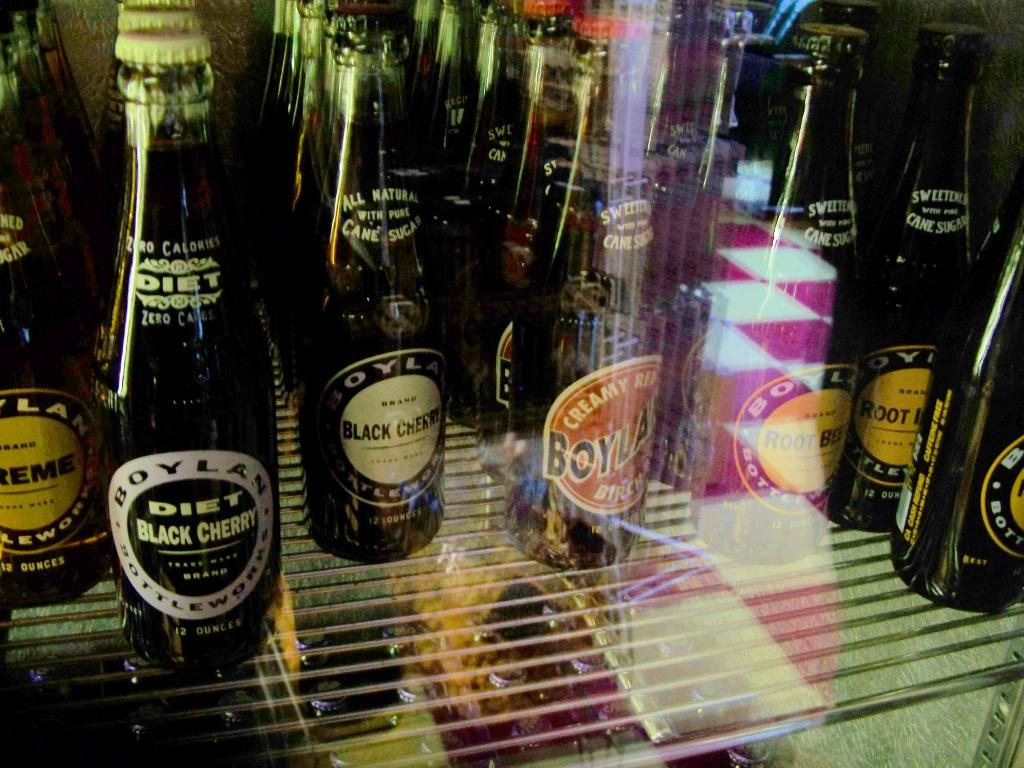Which drink is a diet drink?
Your response must be concise. Black cherry. What is the brand on these bottles?
Offer a very short reply. Boylan. 